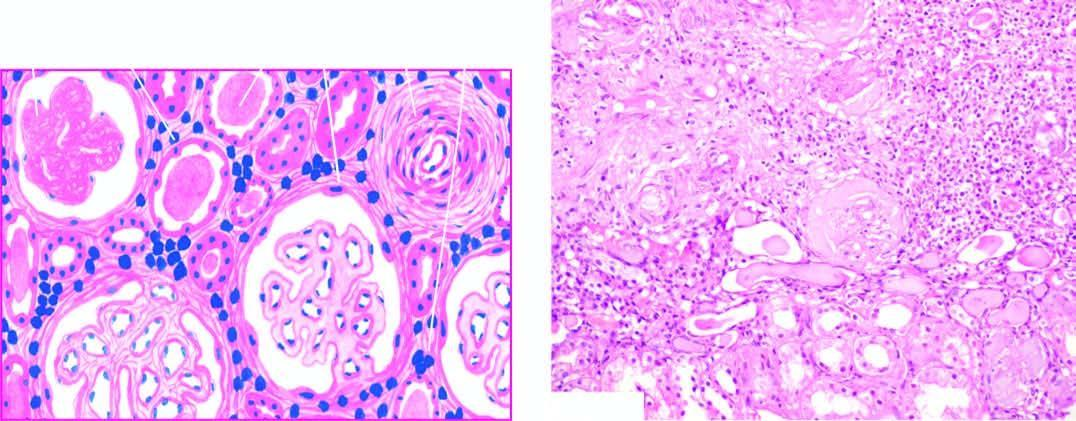do the external surface of small intestine show periglomerular fibrosis?
Answer the question using a single word or phrase. No 